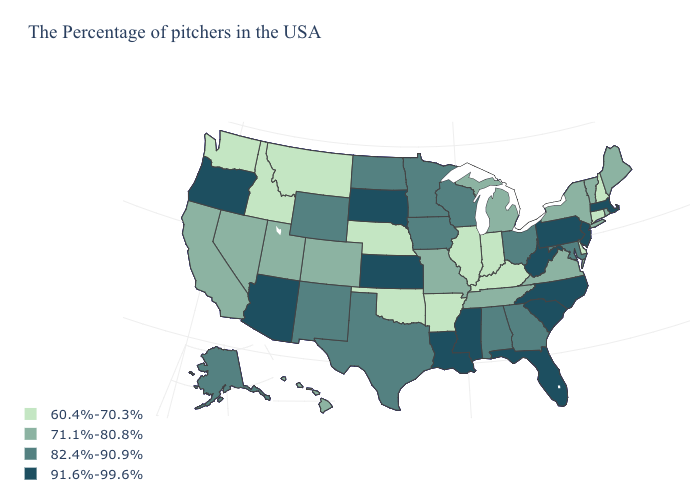What is the value of Delaware?
Quick response, please. 60.4%-70.3%. Name the states that have a value in the range 71.1%-80.8%?
Keep it brief. Maine, Rhode Island, Vermont, New York, Virginia, Michigan, Tennessee, Missouri, Colorado, Utah, Nevada, California, Hawaii. Does California have the highest value in the USA?
Write a very short answer. No. Does Michigan have the same value as Maine?
Short answer required. Yes. Does Mississippi have the same value as Maryland?
Short answer required. No. Among the states that border Utah , does Colorado have the highest value?
Quick response, please. No. What is the value of New Jersey?
Short answer required. 91.6%-99.6%. Which states hav the highest value in the Northeast?
Keep it brief. Massachusetts, New Jersey, Pennsylvania. Which states have the lowest value in the MidWest?
Keep it brief. Indiana, Illinois, Nebraska. What is the value of Montana?
Short answer required. 60.4%-70.3%. What is the highest value in states that border Georgia?
Be succinct. 91.6%-99.6%. Which states hav the highest value in the Northeast?
Short answer required. Massachusetts, New Jersey, Pennsylvania. Does Arizona have the same value as New Jersey?
Concise answer only. Yes. Which states have the lowest value in the USA?
Short answer required. New Hampshire, Connecticut, Delaware, Kentucky, Indiana, Illinois, Arkansas, Nebraska, Oklahoma, Montana, Idaho, Washington. Name the states that have a value in the range 60.4%-70.3%?
Concise answer only. New Hampshire, Connecticut, Delaware, Kentucky, Indiana, Illinois, Arkansas, Nebraska, Oklahoma, Montana, Idaho, Washington. 